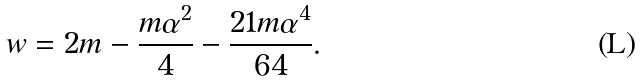<formula> <loc_0><loc_0><loc_500><loc_500>w = 2 m - \frac { m \alpha ^ { 2 } } { 4 } - \frac { 2 1 m \alpha ^ { 4 } } { 6 4 } .</formula> 